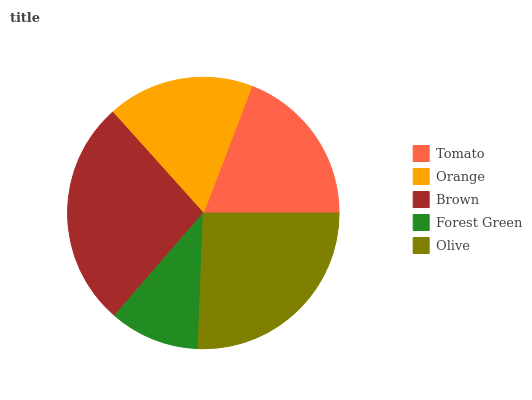Is Forest Green the minimum?
Answer yes or no. Yes. Is Brown the maximum?
Answer yes or no. Yes. Is Orange the minimum?
Answer yes or no. No. Is Orange the maximum?
Answer yes or no. No. Is Tomato greater than Orange?
Answer yes or no. Yes. Is Orange less than Tomato?
Answer yes or no. Yes. Is Orange greater than Tomato?
Answer yes or no. No. Is Tomato less than Orange?
Answer yes or no. No. Is Tomato the high median?
Answer yes or no. Yes. Is Tomato the low median?
Answer yes or no. Yes. Is Brown the high median?
Answer yes or no. No. Is Olive the low median?
Answer yes or no. No. 